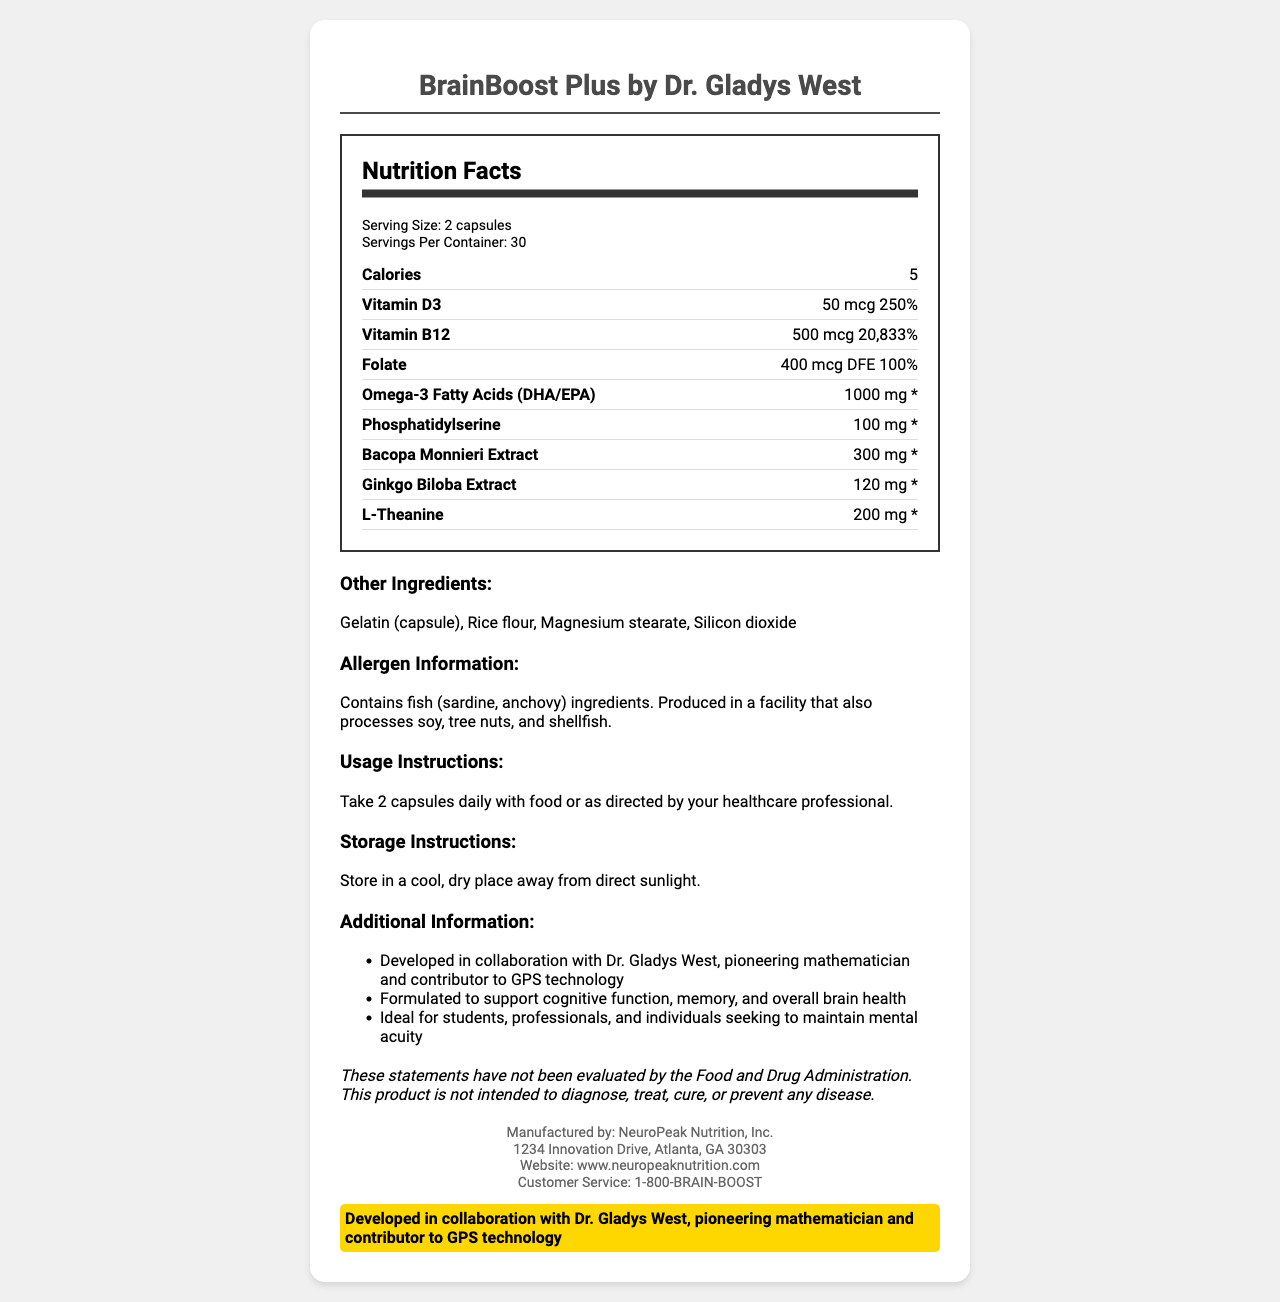what is the serving size for BrainBoost Plus by Dr. Gladys West? The serving size is clearly listed as "2 capsules" in the document.
Answer: 2 capsules how many calories are in one serving? The calories per serving information is provided as "5 calories" in the document.
Answer: 5 calories which nutrient has the highest daily value percentage? The daily value percentages are listed for each nutrient. Vitamin B12 has a daily value of "20,833%", which is the highest.
Answer: Vitamin B12 how many servings are in one container? The servings per container is mentioned as "30" in the document.
Answer: 30 servings who endorsed the BrainBoost Plus supplement? The supplement is endorsed by Dr. Gladys West, as stated in the document.
Answer: Dr. Gladys West which of the following is not an ingredient in BrainBoost Plus? A. Gelatin B. Rice flour C. Milk The document lists other ingredients such as "Gelatin (capsule), Rice flour, Magnesium stearate, Silicon dioxide" but does not mention milk.
Answer: C. Milk which vitamin is present in the largest amount per serving? A. Vitamin D3 B. Vitamin B12 C. Folate The document lists Vitamin B12 at 500 mcg per serving, which is the largest amount compared to the other vitamins listed.
Answer: B. Vitamin B12 is BrainBoost Plus suitable for vegans? The document lists gelatin and fish ingredients (sardine, anchovy) which are not suitable for vegans.
Answer: No summarize the key features of BrainBoost Plus by Dr. Gladys West. The document describes the product, its purpose, key ingredients, and instructions for use and storage, highlighting Dr. Gladys West's endorsement.
Answer: BrainBoost Plus by Dr. Gladys West is a brain health supplement designed to support cognitive function, memory, and overall brain health. It contains various nutrients, including high amounts of Vitamin B12, Omega-3 Fatty Acids, and Bacopa Monnieri Extract. Endorsed by Dr. Gladys West, it is ideal for students, professionals, and individuals seeking to maintain mental acuity. The supplement should be taken as directed and stored properly. how many milligrams of Omega-3 Fatty Acids are included per serving? The document lists Omega-3 Fatty Acids (DHA/EPA) amount as 1000 mg per serving.
Answer: 1000 mg what company manufactures BrainBoost Plus? The manufacturer's information is provided as "NeuroPeak Nutrition, Inc." in the document.
Answer: NeuroPeak Nutrition, Inc. does BrainBoost Plus include any tree nuts in its ingredients? The allergen information states that it is produced in a facility that processes tree nuts, but does not directly list tree nuts as an ingredient.
Answer: Produced in a facility that also processes tree nuts is the daily value for L-Theanine specified? The document lists the amount for L-Theanine but notes the daily value as "*" indicating it is not specified.
Answer: No what role did Dr. Gladys West play in the development of BrainBoost Plus? The document mentions that Dr. Gladys West is not only an endorser but also developed the product in collaboration with the manufacturer.
Answer: Contributor and endorser what is the recommended daily dosage for BrainBoost Plus? The usage instructions recommend taking 2 capsules daily with food.
Answer: 2 capsules daily with food or as directed by a healthcare professional is there any information about the effectiveness of BrainBoost Plus according to the FDA? The disclaimer states that the statements have not been evaluated by the FDA and that the product is not intended to diagnose, treat, cure, or prevent any disease.
Answer: No 